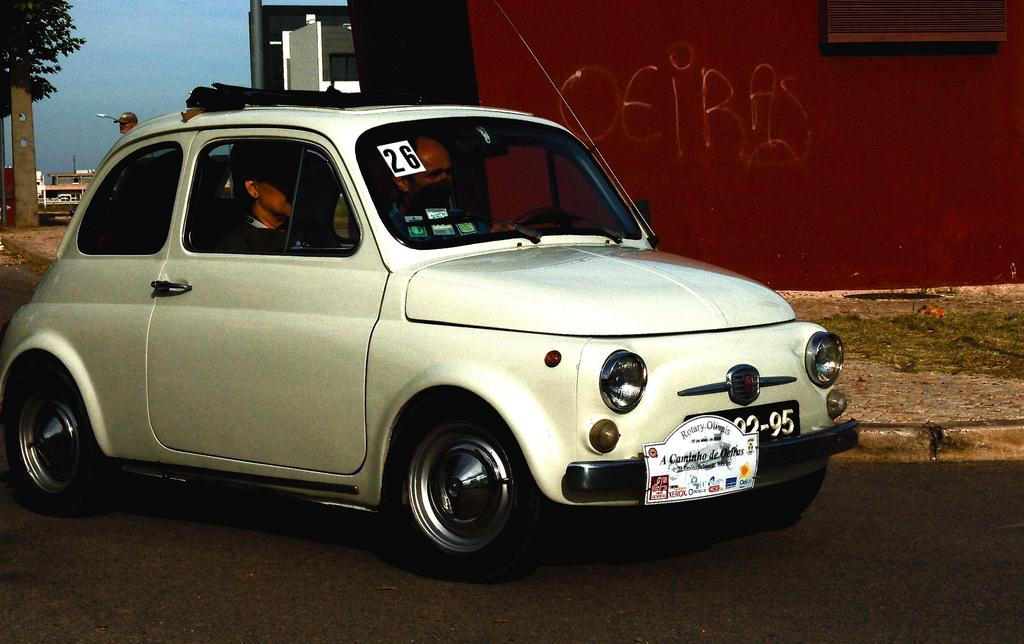Where was the image taken? The image was taken on the road. What is the main subject in the image? There is a car in the center of the image. Who is inside the car? Two people are sitting in the car. What can be seen in the background of the image? There is a building, a tree, and the sky visible in the background of the image. What type of skirt is the tree wearing in the image? There is no skirt present in the image, as the tree is a natural object and does not wear clothing. 